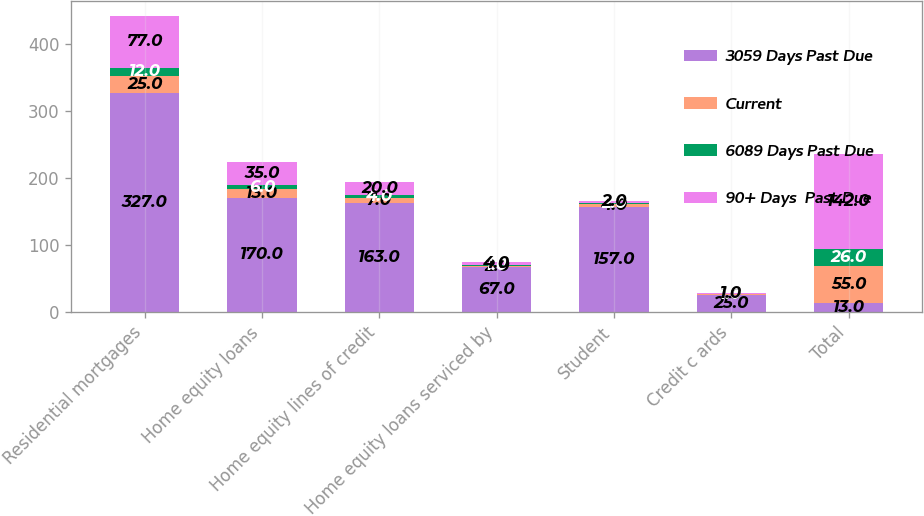<chart> <loc_0><loc_0><loc_500><loc_500><stacked_bar_chart><ecel><fcel>Residential mortgages<fcel>Home equity loans<fcel>Home equity lines of credit<fcel>Home equity loans serviced by<fcel>Student<fcel>Credit c ards<fcel>Total<nl><fcel>3059 Days Past Due<fcel>327<fcel>170<fcel>163<fcel>67<fcel>157<fcel>25<fcel>13<nl><fcel>Current<fcel>25<fcel>13<fcel>7<fcel>2<fcel>4<fcel>1<fcel>55<nl><fcel>6089 Days Past Due<fcel>12<fcel>6<fcel>4<fcel>1<fcel>2<fcel>1<fcel>26<nl><fcel>90+ Days  Past Due<fcel>77<fcel>35<fcel>20<fcel>4<fcel>2<fcel>1<fcel>142<nl></chart> 